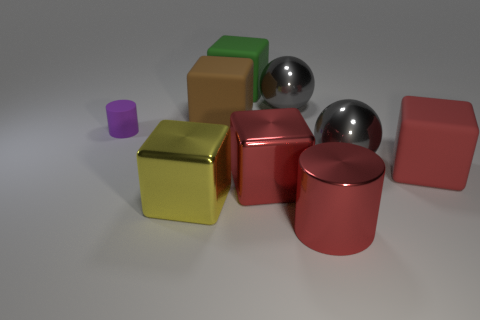Do the green block and the red cylinder have the same size?
Your response must be concise. Yes. There is a small cylinder; does it have the same color as the matte block that is on the right side of the green matte block?
Ensure brevity in your answer.  No. The green object that is made of the same material as the big brown block is what shape?
Your answer should be compact. Cube. Is the shape of the gray thing in front of the small purple object the same as  the purple matte thing?
Keep it short and to the point. No. What size is the yellow block left of the large red metal object behind the red cylinder?
Provide a succinct answer. Large. What color is the small cylinder that is made of the same material as the large green object?
Your response must be concise. Purple. How many gray metal objects have the same size as the metal cylinder?
Provide a succinct answer. 2. What number of gray things are either rubber cylinders or metal spheres?
Your response must be concise. 2. How many things are green things or metal cubes on the right side of the large green matte thing?
Your answer should be very brief. 2. What is the material of the cylinder that is right of the large green object?
Your answer should be very brief. Metal. 